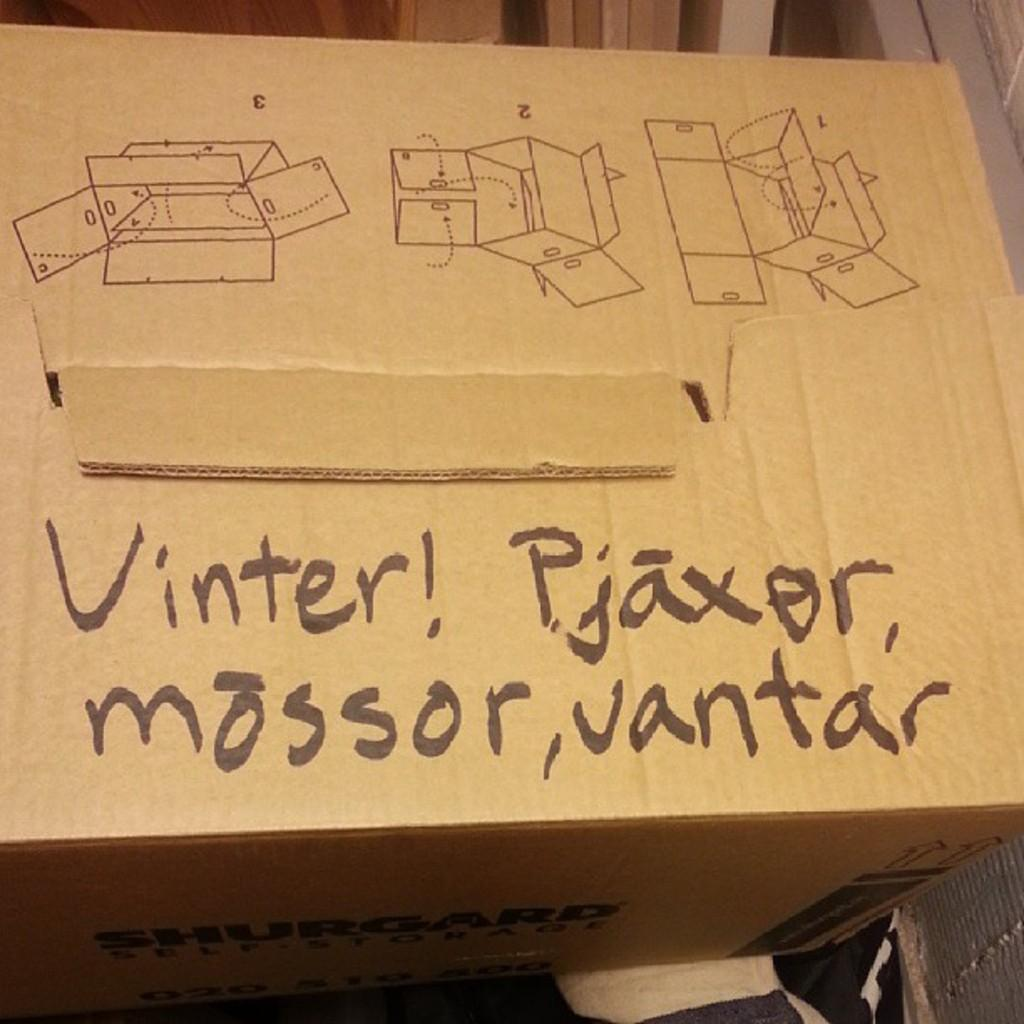<image>
Provide a brief description of the given image. A box that has writing on top that says Vinter! Pjaxor mossor, vantar. 